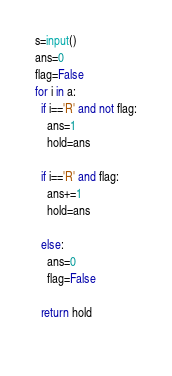<code> <loc_0><loc_0><loc_500><loc_500><_Python_>s=input()
ans=0
flag=False
for i in a:
  if i=='R' and not flag:
    ans=1
    hold=ans
    
  if i=='R' and flag:
    ans+=1
    hold=ans
    
  else:
    ans=0
    flag=False
    
  return hold
    </code> 